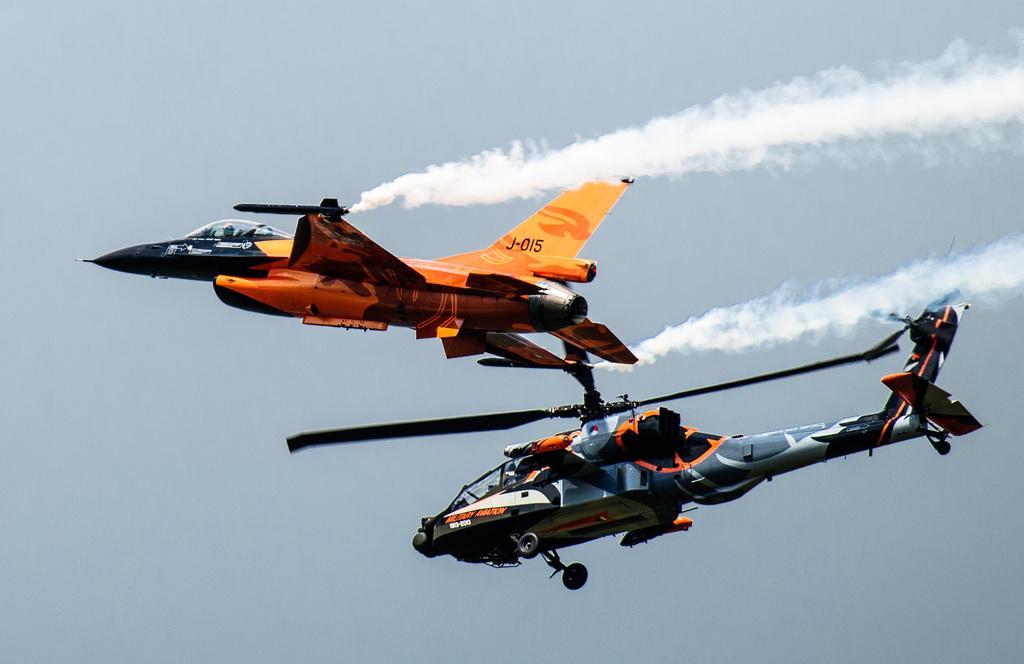Describe this image in one or two sentences. In this image I can see a helicopter and an aeroplane is flying in the air towards the left side. At the back of the aeroplane I can see the fume. In the background, I can see the sky. 